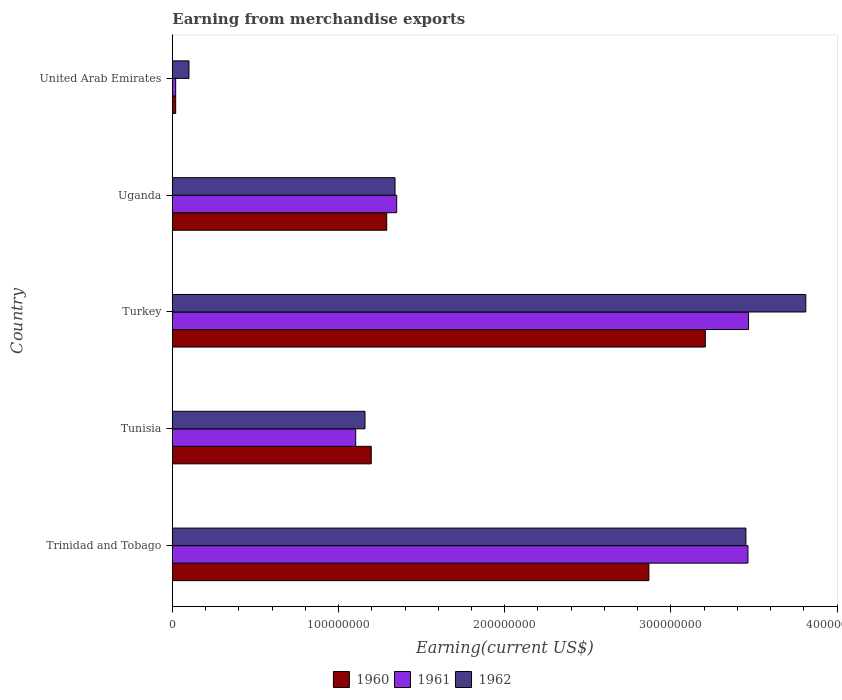How many groups of bars are there?
Your response must be concise. 5. Are the number of bars on each tick of the Y-axis equal?
Offer a terse response. Yes. How many bars are there on the 5th tick from the top?
Your response must be concise. 3. How many bars are there on the 3rd tick from the bottom?
Offer a terse response. 3. What is the label of the 1st group of bars from the top?
Your answer should be compact. United Arab Emirates. What is the amount earned from merchandise exports in 1962 in Uganda?
Keep it short and to the point. 1.34e+08. Across all countries, what is the maximum amount earned from merchandise exports in 1960?
Your answer should be compact. 3.21e+08. Across all countries, what is the minimum amount earned from merchandise exports in 1962?
Keep it short and to the point. 1.00e+07. In which country was the amount earned from merchandise exports in 1960 minimum?
Your answer should be compact. United Arab Emirates. What is the total amount earned from merchandise exports in 1961 in the graph?
Ensure brevity in your answer.  9.40e+08. What is the difference between the amount earned from merchandise exports in 1961 in Uganda and that in United Arab Emirates?
Your answer should be very brief. 1.33e+08. What is the difference between the amount earned from merchandise exports in 1961 in Tunisia and the amount earned from merchandise exports in 1962 in Trinidad and Tobago?
Ensure brevity in your answer.  -2.35e+08. What is the average amount earned from merchandise exports in 1961 per country?
Give a very brief answer. 1.88e+08. What is the difference between the amount earned from merchandise exports in 1961 and amount earned from merchandise exports in 1962 in Tunisia?
Keep it short and to the point. -5.60e+06. What is the ratio of the amount earned from merchandise exports in 1962 in Tunisia to that in Turkey?
Make the answer very short. 0.3. Is the amount earned from merchandise exports in 1962 in Trinidad and Tobago less than that in Uganda?
Your answer should be compact. No. What is the difference between the highest and the second highest amount earned from merchandise exports in 1961?
Keep it short and to the point. 3.58e+05. What is the difference between the highest and the lowest amount earned from merchandise exports in 1962?
Your response must be concise. 3.71e+08. In how many countries, is the amount earned from merchandise exports in 1962 greater than the average amount earned from merchandise exports in 1962 taken over all countries?
Your answer should be compact. 2. Is the sum of the amount earned from merchandise exports in 1962 in Tunisia and United Arab Emirates greater than the maximum amount earned from merchandise exports in 1960 across all countries?
Make the answer very short. No. What does the 3rd bar from the bottom in United Arab Emirates represents?
Offer a very short reply. 1962. How many bars are there?
Give a very brief answer. 15. Are all the bars in the graph horizontal?
Provide a succinct answer. Yes. What is the difference between two consecutive major ticks on the X-axis?
Offer a very short reply. 1.00e+08. Does the graph contain any zero values?
Ensure brevity in your answer.  No. Does the graph contain grids?
Keep it short and to the point. No. Where does the legend appear in the graph?
Provide a succinct answer. Bottom center. How many legend labels are there?
Provide a short and direct response. 3. What is the title of the graph?
Your answer should be compact. Earning from merchandise exports. Does "1979" appear as one of the legend labels in the graph?
Ensure brevity in your answer.  No. What is the label or title of the X-axis?
Give a very brief answer. Earning(current US$). What is the label or title of the Y-axis?
Your response must be concise. Country. What is the Earning(current US$) of 1960 in Trinidad and Tobago?
Offer a terse response. 2.87e+08. What is the Earning(current US$) of 1961 in Trinidad and Tobago?
Make the answer very short. 3.46e+08. What is the Earning(current US$) of 1962 in Trinidad and Tobago?
Your answer should be compact. 3.45e+08. What is the Earning(current US$) of 1960 in Tunisia?
Ensure brevity in your answer.  1.20e+08. What is the Earning(current US$) of 1961 in Tunisia?
Your answer should be very brief. 1.10e+08. What is the Earning(current US$) of 1962 in Tunisia?
Your answer should be very brief. 1.16e+08. What is the Earning(current US$) of 1960 in Turkey?
Provide a short and direct response. 3.21e+08. What is the Earning(current US$) in 1961 in Turkey?
Give a very brief answer. 3.47e+08. What is the Earning(current US$) in 1962 in Turkey?
Your answer should be very brief. 3.81e+08. What is the Earning(current US$) in 1960 in Uganda?
Offer a very short reply. 1.29e+08. What is the Earning(current US$) of 1961 in Uganda?
Make the answer very short. 1.35e+08. What is the Earning(current US$) in 1962 in Uganda?
Offer a terse response. 1.34e+08. Across all countries, what is the maximum Earning(current US$) in 1960?
Ensure brevity in your answer.  3.21e+08. Across all countries, what is the maximum Earning(current US$) in 1961?
Provide a short and direct response. 3.47e+08. Across all countries, what is the maximum Earning(current US$) of 1962?
Provide a short and direct response. 3.81e+08. Across all countries, what is the minimum Earning(current US$) of 1960?
Offer a very short reply. 2.00e+06. What is the total Earning(current US$) of 1960 in the graph?
Keep it short and to the point. 8.58e+08. What is the total Earning(current US$) in 1961 in the graph?
Make the answer very short. 9.40e+08. What is the total Earning(current US$) of 1962 in the graph?
Provide a short and direct response. 9.86e+08. What is the difference between the Earning(current US$) of 1960 in Trinidad and Tobago and that in Tunisia?
Provide a succinct answer. 1.67e+08. What is the difference between the Earning(current US$) of 1961 in Trinidad and Tobago and that in Tunisia?
Your answer should be very brief. 2.36e+08. What is the difference between the Earning(current US$) in 1962 in Trinidad and Tobago and that in Tunisia?
Offer a very short reply. 2.29e+08. What is the difference between the Earning(current US$) in 1960 in Trinidad and Tobago and that in Turkey?
Your response must be concise. -3.40e+07. What is the difference between the Earning(current US$) in 1961 in Trinidad and Tobago and that in Turkey?
Ensure brevity in your answer.  -3.58e+05. What is the difference between the Earning(current US$) in 1962 in Trinidad and Tobago and that in Turkey?
Your response must be concise. -3.60e+07. What is the difference between the Earning(current US$) in 1960 in Trinidad and Tobago and that in Uganda?
Your answer should be compact. 1.58e+08. What is the difference between the Earning(current US$) of 1961 in Trinidad and Tobago and that in Uganda?
Offer a very short reply. 2.11e+08. What is the difference between the Earning(current US$) of 1962 in Trinidad and Tobago and that in Uganda?
Provide a succinct answer. 2.11e+08. What is the difference between the Earning(current US$) in 1960 in Trinidad and Tobago and that in United Arab Emirates?
Your response must be concise. 2.85e+08. What is the difference between the Earning(current US$) of 1961 in Trinidad and Tobago and that in United Arab Emirates?
Keep it short and to the point. 3.44e+08. What is the difference between the Earning(current US$) in 1962 in Trinidad and Tobago and that in United Arab Emirates?
Your answer should be very brief. 3.35e+08. What is the difference between the Earning(current US$) of 1960 in Tunisia and that in Turkey?
Your answer should be very brief. -2.01e+08. What is the difference between the Earning(current US$) in 1961 in Tunisia and that in Turkey?
Keep it short and to the point. -2.36e+08. What is the difference between the Earning(current US$) in 1962 in Tunisia and that in Turkey?
Offer a very short reply. -2.65e+08. What is the difference between the Earning(current US$) in 1960 in Tunisia and that in Uganda?
Make the answer very short. -9.31e+06. What is the difference between the Earning(current US$) in 1961 in Tunisia and that in Uganda?
Offer a terse response. -2.47e+07. What is the difference between the Earning(current US$) of 1962 in Tunisia and that in Uganda?
Provide a succinct answer. -1.81e+07. What is the difference between the Earning(current US$) in 1960 in Tunisia and that in United Arab Emirates?
Offer a terse response. 1.18e+08. What is the difference between the Earning(current US$) in 1961 in Tunisia and that in United Arab Emirates?
Provide a succinct answer. 1.08e+08. What is the difference between the Earning(current US$) in 1962 in Tunisia and that in United Arab Emirates?
Make the answer very short. 1.06e+08. What is the difference between the Earning(current US$) in 1960 in Turkey and that in Uganda?
Offer a terse response. 1.92e+08. What is the difference between the Earning(current US$) in 1961 in Turkey and that in Uganda?
Your answer should be very brief. 2.12e+08. What is the difference between the Earning(current US$) in 1962 in Turkey and that in Uganda?
Your answer should be very brief. 2.47e+08. What is the difference between the Earning(current US$) in 1960 in Turkey and that in United Arab Emirates?
Keep it short and to the point. 3.19e+08. What is the difference between the Earning(current US$) in 1961 in Turkey and that in United Arab Emirates?
Keep it short and to the point. 3.45e+08. What is the difference between the Earning(current US$) in 1962 in Turkey and that in United Arab Emirates?
Ensure brevity in your answer.  3.71e+08. What is the difference between the Earning(current US$) in 1960 in Uganda and that in United Arab Emirates?
Offer a very short reply. 1.27e+08. What is the difference between the Earning(current US$) in 1961 in Uganda and that in United Arab Emirates?
Ensure brevity in your answer.  1.33e+08. What is the difference between the Earning(current US$) of 1962 in Uganda and that in United Arab Emirates?
Your response must be concise. 1.24e+08. What is the difference between the Earning(current US$) in 1960 in Trinidad and Tobago and the Earning(current US$) in 1961 in Tunisia?
Offer a terse response. 1.76e+08. What is the difference between the Earning(current US$) of 1960 in Trinidad and Tobago and the Earning(current US$) of 1962 in Tunisia?
Your response must be concise. 1.71e+08. What is the difference between the Earning(current US$) of 1961 in Trinidad and Tobago and the Earning(current US$) of 1962 in Tunisia?
Provide a succinct answer. 2.30e+08. What is the difference between the Earning(current US$) of 1960 in Trinidad and Tobago and the Earning(current US$) of 1961 in Turkey?
Your answer should be compact. -6.00e+07. What is the difference between the Earning(current US$) of 1960 in Trinidad and Tobago and the Earning(current US$) of 1962 in Turkey?
Keep it short and to the point. -9.44e+07. What is the difference between the Earning(current US$) of 1961 in Trinidad and Tobago and the Earning(current US$) of 1962 in Turkey?
Provide a succinct answer. -3.48e+07. What is the difference between the Earning(current US$) in 1960 in Trinidad and Tobago and the Earning(current US$) in 1961 in Uganda?
Provide a succinct answer. 1.52e+08. What is the difference between the Earning(current US$) of 1960 in Trinidad and Tobago and the Earning(current US$) of 1962 in Uganda?
Your response must be concise. 1.53e+08. What is the difference between the Earning(current US$) of 1961 in Trinidad and Tobago and the Earning(current US$) of 1962 in Uganda?
Keep it short and to the point. 2.12e+08. What is the difference between the Earning(current US$) in 1960 in Trinidad and Tobago and the Earning(current US$) in 1961 in United Arab Emirates?
Offer a terse response. 2.85e+08. What is the difference between the Earning(current US$) of 1960 in Trinidad and Tobago and the Earning(current US$) of 1962 in United Arab Emirates?
Keep it short and to the point. 2.77e+08. What is the difference between the Earning(current US$) of 1961 in Trinidad and Tobago and the Earning(current US$) of 1962 in United Arab Emirates?
Ensure brevity in your answer.  3.36e+08. What is the difference between the Earning(current US$) of 1960 in Tunisia and the Earning(current US$) of 1961 in Turkey?
Offer a terse response. -2.27e+08. What is the difference between the Earning(current US$) of 1960 in Tunisia and the Earning(current US$) of 1962 in Turkey?
Make the answer very short. -2.62e+08. What is the difference between the Earning(current US$) of 1961 in Tunisia and the Earning(current US$) of 1962 in Turkey?
Make the answer very short. -2.71e+08. What is the difference between the Earning(current US$) of 1960 in Tunisia and the Earning(current US$) of 1961 in Uganda?
Provide a succinct answer. -1.53e+07. What is the difference between the Earning(current US$) of 1960 in Tunisia and the Earning(current US$) of 1962 in Uganda?
Offer a terse response. -1.43e+07. What is the difference between the Earning(current US$) in 1961 in Tunisia and the Earning(current US$) in 1962 in Uganda?
Your answer should be compact. -2.37e+07. What is the difference between the Earning(current US$) in 1960 in Tunisia and the Earning(current US$) in 1961 in United Arab Emirates?
Offer a very short reply. 1.18e+08. What is the difference between the Earning(current US$) of 1960 in Tunisia and the Earning(current US$) of 1962 in United Arab Emirates?
Make the answer very short. 1.10e+08. What is the difference between the Earning(current US$) in 1961 in Tunisia and the Earning(current US$) in 1962 in United Arab Emirates?
Offer a very short reply. 1.00e+08. What is the difference between the Earning(current US$) of 1960 in Turkey and the Earning(current US$) of 1961 in Uganda?
Give a very brief answer. 1.86e+08. What is the difference between the Earning(current US$) of 1960 in Turkey and the Earning(current US$) of 1962 in Uganda?
Provide a short and direct response. 1.87e+08. What is the difference between the Earning(current US$) of 1961 in Turkey and the Earning(current US$) of 1962 in Uganda?
Your answer should be compact. 2.13e+08. What is the difference between the Earning(current US$) in 1960 in Turkey and the Earning(current US$) in 1961 in United Arab Emirates?
Offer a very short reply. 3.19e+08. What is the difference between the Earning(current US$) of 1960 in Turkey and the Earning(current US$) of 1962 in United Arab Emirates?
Your response must be concise. 3.11e+08. What is the difference between the Earning(current US$) of 1961 in Turkey and the Earning(current US$) of 1962 in United Arab Emirates?
Your answer should be very brief. 3.37e+08. What is the difference between the Earning(current US$) of 1960 in Uganda and the Earning(current US$) of 1961 in United Arab Emirates?
Ensure brevity in your answer.  1.27e+08. What is the difference between the Earning(current US$) of 1960 in Uganda and the Earning(current US$) of 1962 in United Arab Emirates?
Provide a succinct answer. 1.19e+08. What is the difference between the Earning(current US$) of 1961 in Uganda and the Earning(current US$) of 1962 in United Arab Emirates?
Ensure brevity in your answer.  1.25e+08. What is the average Earning(current US$) in 1960 per country?
Provide a short and direct response. 1.72e+08. What is the average Earning(current US$) in 1961 per country?
Your answer should be very brief. 1.88e+08. What is the average Earning(current US$) of 1962 per country?
Offer a very short reply. 1.97e+08. What is the difference between the Earning(current US$) in 1960 and Earning(current US$) in 1961 in Trinidad and Tobago?
Your answer should be very brief. -5.96e+07. What is the difference between the Earning(current US$) in 1960 and Earning(current US$) in 1962 in Trinidad and Tobago?
Provide a succinct answer. -5.84e+07. What is the difference between the Earning(current US$) in 1961 and Earning(current US$) in 1962 in Trinidad and Tobago?
Offer a very short reply. 1.22e+06. What is the difference between the Earning(current US$) in 1960 and Earning(current US$) in 1961 in Tunisia?
Your answer should be very brief. 9.36e+06. What is the difference between the Earning(current US$) in 1960 and Earning(current US$) in 1962 in Tunisia?
Ensure brevity in your answer.  3.76e+06. What is the difference between the Earning(current US$) of 1961 and Earning(current US$) of 1962 in Tunisia?
Provide a succinct answer. -5.60e+06. What is the difference between the Earning(current US$) of 1960 and Earning(current US$) of 1961 in Turkey?
Give a very brief answer. -2.60e+07. What is the difference between the Earning(current US$) of 1960 and Earning(current US$) of 1962 in Turkey?
Ensure brevity in your answer.  -6.05e+07. What is the difference between the Earning(current US$) in 1961 and Earning(current US$) in 1962 in Turkey?
Your answer should be compact. -3.45e+07. What is the difference between the Earning(current US$) in 1960 and Earning(current US$) in 1961 in Uganda?
Give a very brief answer. -6.00e+06. What is the difference between the Earning(current US$) in 1960 and Earning(current US$) in 1962 in Uganda?
Make the answer very short. -5.00e+06. What is the difference between the Earning(current US$) of 1961 and Earning(current US$) of 1962 in Uganda?
Offer a very short reply. 1.00e+06. What is the difference between the Earning(current US$) in 1960 and Earning(current US$) in 1962 in United Arab Emirates?
Provide a succinct answer. -8.00e+06. What is the difference between the Earning(current US$) in 1961 and Earning(current US$) in 1962 in United Arab Emirates?
Make the answer very short. -8.00e+06. What is the ratio of the Earning(current US$) in 1960 in Trinidad and Tobago to that in Tunisia?
Make the answer very short. 2.4. What is the ratio of the Earning(current US$) of 1961 in Trinidad and Tobago to that in Tunisia?
Keep it short and to the point. 3.14. What is the ratio of the Earning(current US$) in 1962 in Trinidad and Tobago to that in Tunisia?
Your answer should be very brief. 2.98. What is the ratio of the Earning(current US$) in 1960 in Trinidad and Tobago to that in Turkey?
Make the answer very short. 0.89. What is the ratio of the Earning(current US$) of 1961 in Trinidad and Tobago to that in Turkey?
Provide a short and direct response. 1. What is the ratio of the Earning(current US$) in 1962 in Trinidad and Tobago to that in Turkey?
Give a very brief answer. 0.91. What is the ratio of the Earning(current US$) in 1960 in Trinidad and Tobago to that in Uganda?
Give a very brief answer. 2.22. What is the ratio of the Earning(current US$) of 1961 in Trinidad and Tobago to that in Uganda?
Your answer should be compact. 2.57. What is the ratio of the Earning(current US$) in 1962 in Trinidad and Tobago to that in Uganda?
Offer a terse response. 2.58. What is the ratio of the Earning(current US$) of 1960 in Trinidad and Tobago to that in United Arab Emirates?
Give a very brief answer. 143.38. What is the ratio of the Earning(current US$) of 1961 in Trinidad and Tobago to that in United Arab Emirates?
Your answer should be compact. 173.19. What is the ratio of the Earning(current US$) of 1962 in Trinidad and Tobago to that in United Arab Emirates?
Keep it short and to the point. 34.52. What is the ratio of the Earning(current US$) of 1960 in Tunisia to that in Turkey?
Offer a terse response. 0.37. What is the ratio of the Earning(current US$) of 1961 in Tunisia to that in Turkey?
Offer a very short reply. 0.32. What is the ratio of the Earning(current US$) of 1962 in Tunisia to that in Turkey?
Ensure brevity in your answer.  0.3. What is the ratio of the Earning(current US$) in 1960 in Tunisia to that in Uganda?
Keep it short and to the point. 0.93. What is the ratio of the Earning(current US$) of 1961 in Tunisia to that in Uganda?
Offer a very short reply. 0.82. What is the ratio of the Earning(current US$) in 1962 in Tunisia to that in Uganda?
Keep it short and to the point. 0.87. What is the ratio of the Earning(current US$) of 1960 in Tunisia to that in United Arab Emirates?
Your answer should be very brief. 59.84. What is the ratio of the Earning(current US$) in 1961 in Tunisia to that in United Arab Emirates?
Ensure brevity in your answer.  55.17. What is the ratio of the Earning(current US$) of 1962 in Tunisia to that in United Arab Emirates?
Your answer should be compact. 11.59. What is the ratio of the Earning(current US$) of 1960 in Turkey to that in Uganda?
Ensure brevity in your answer.  2.49. What is the ratio of the Earning(current US$) of 1961 in Turkey to that in Uganda?
Offer a very short reply. 2.57. What is the ratio of the Earning(current US$) of 1962 in Turkey to that in Uganda?
Ensure brevity in your answer.  2.84. What is the ratio of the Earning(current US$) in 1960 in Turkey to that in United Arab Emirates?
Provide a short and direct response. 160.37. What is the ratio of the Earning(current US$) of 1961 in Turkey to that in United Arab Emirates?
Your response must be concise. 173.37. What is the ratio of the Earning(current US$) of 1962 in Turkey to that in United Arab Emirates?
Give a very brief answer. 38.12. What is the ratio of the Earning(current US$) of 1960 in Uganda to that in United Arab Emirates?
Your answer should be very brief. 64.5. What is the ratio of the Earning(current US$) of 1961 in Uganda to that in United Arab Emirates?
Your response must be concise. 67.5. What is the ratio of the Earning(current US$) in 1962 in Uganda to that in United Arab Emirates?
Provide a short and direct response. 13.4. What is the difference between the highest and the second highest Earning(current US$) in 1960?
Keep it short and to the point. 3.40e+07. What is the difference between the highest and the second highest Earning(current US$) of 1961?
Ensure brevity in your answer.  3.58e+05. What is the difference between the highest and the second highest Earning(current US$) of 1962?
Give a very brief answer. 3.60e+07. What is the difference between the highest and the lowest Earning(current US$) in 1960?
Give a very brief answer. 3.19e+08. What is the difference between the highest and the lowest Earning(current US$) of 1961?
Ensure brevity in your answer.  3.45e+08. What is the difference between the highest and the lowest Earning(current US$) in 1962?
Your response must be concise. 3.71e+08. 